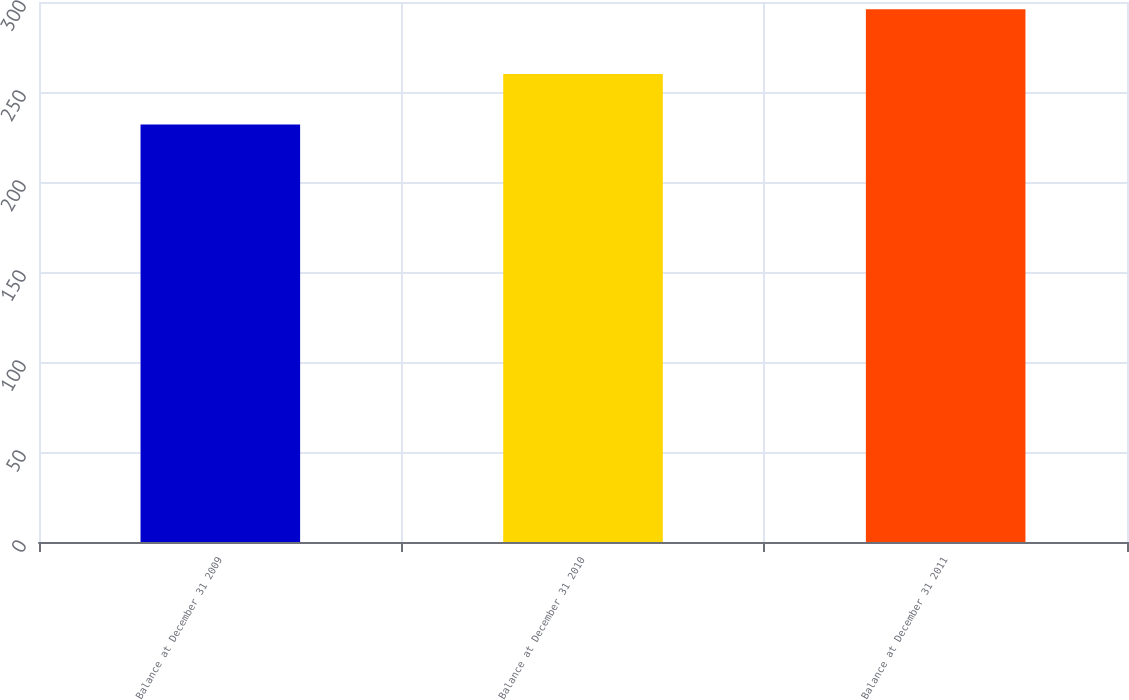Convert chart to OTSL. <chart><loc_0><loc_0><loc_500><loc_500><bar_chart><fcel>Balance at December 31 2009<fcel>Balance at December 31 2010<fcel>Balance at December 31 2011<nl><fcel>232<fcel>260<fcel>296<nl></chart> 